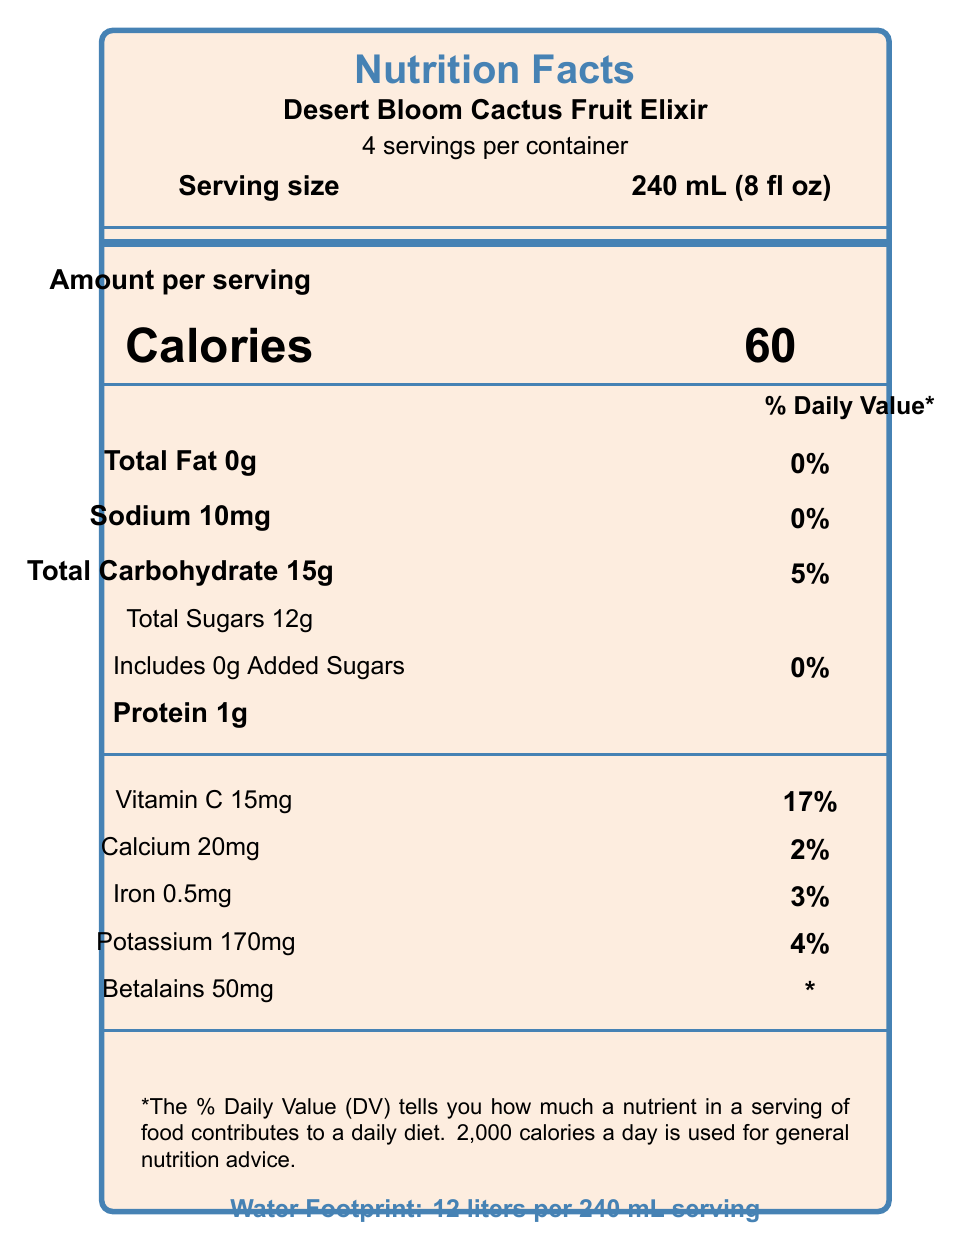what is the serving size of the Desert Bloom Cactus Fruit Elixir? The document states the serving size as 240 mL (8 fl oz).
Answer: 240 mL (8 fl oz) how many total servings are in the container? The document mentions "4 servings per container."
Answer: 4 how many calories are there per serving? The number of calories per serving is listed directly underneath the "Calories" section.
Answer: 60 what is the percentage of Daily Value for Vitamin C per serving? The percentage of Daily Value for Vitamin C per serving is indicated as 17%.
Answer: 17% list one of the sustainability facts mentioned in the document. The document contains multiple sustainability facts, one of which is "Sourced from drought-resistant Opuntia ficus-indica cacti."
Answer: Sourced from drought-resistant Opuntia ficus-indica cacti what makes the cactus fruit elixir unique in its antioxidant properties? A. High vitamin A B. High vitamin D C. Rich in betalains D. High fiber The antioxidant properties list that the elixir is "Rich in betalains, powerful antioxidants unique to cacti."
Answer: C. Rich in betalains how much potassium is in one serving? A. 20mg B. 170mg C. 10mg D. 60mg The potassium content per serving is listed as 170mg.
Answer: B. 170mg is there any added sugar in the Desert Bloom Cactus Fruit Elixir? The document specifies that the total sugars include 0g of added sugars.
Answer: No is the product certified USDA Organic? The document lists "USDA Organic" under certification.
Answer: Yes summarize the main idea of the document. This summary encapsulates the key points described in the document including nutritional information, unique properties of the elixir, and sustainability aspects.
Answer: The document provides the nutrition facts of "Desert Bloom Cactus Fruit Elixir," a sustainable and antioxidant-rich beverage with low water footprint. It details serving size, nutrient content, ingredient list, sustainability and antioxidant benefits, and certification. what is the total weight of the container? The document does not provide information about the total weight of the container.
Answer: Cannot be determined 